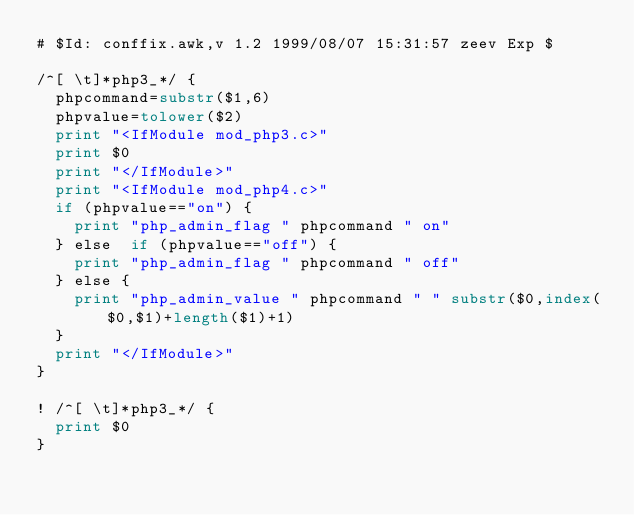Convert code to text. <code><loc_0><loc_0><loc_500><loc_500><_Awk_># $Id: conffix.awk,v 1.2 1999/08/07 15:31:57 zeev Exp $

/^[ \t]*php3_*/ {
	phpcommand=substr($1,6)
	phpvalue=tolower($2)
	print "<IfModule mod_php3.c>"
	print $0
	print "</IfModule>"
	print "<IfModule mod_php4.c>"
	if (phpvalue=="on") {
		print "php_admin_flag " phpcommand " on"
	} else  if (phpvalue=="off") {
		print "php_admin_flag " phpcommand " off"
	} else {
		print "php_admin_value " phpcommand " " substr($0,index($0,$1)+length($1)+1)
	}
	print "</IfModule>"
}

! /^[ \t]*php3_*/ {
	print $0
}

</code> 